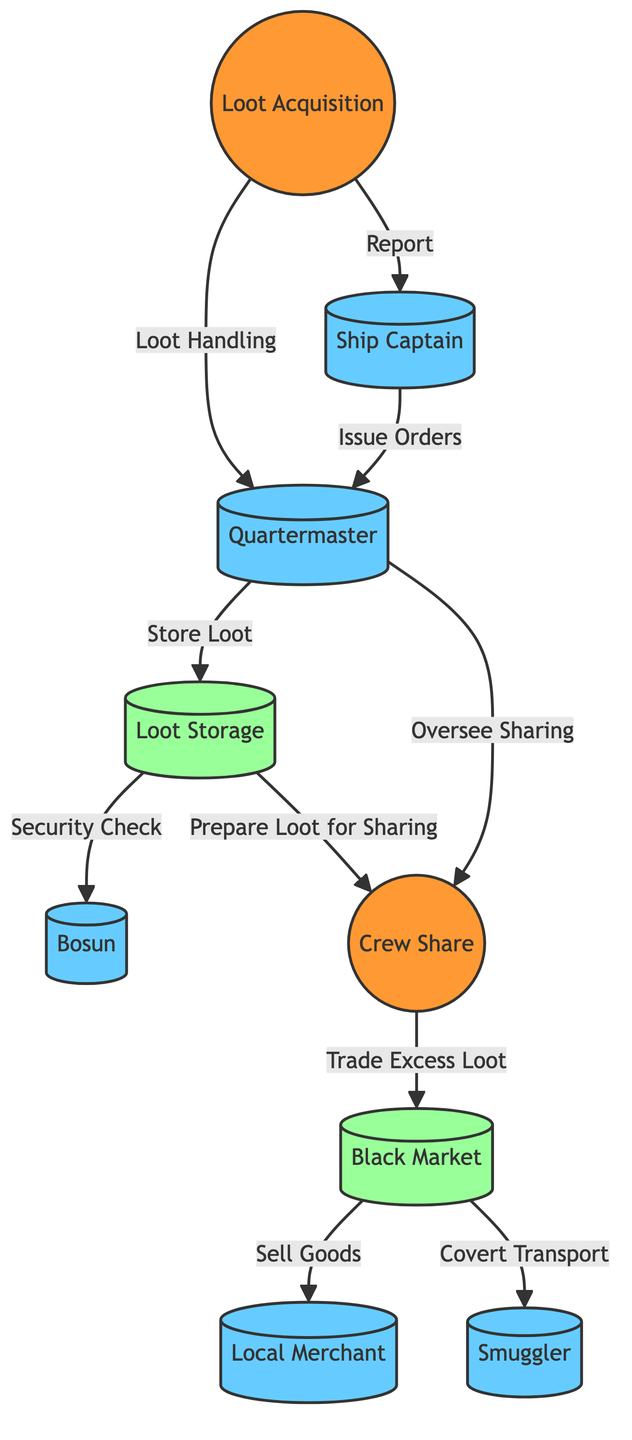What is the primary activity to obtain treasure? The primary activity to obtain treasure is "Loot Acquisition," as indicated in the diagram. This node is where the process begins and involves actions like raiding ships and finding buried treasure.
Answer: Loot Acquisition Who oversees the distribution of loot among the crew? The "Quartermaster" oversees the distribution of loot according to the diagram. The edges clearly show that the quartermaster is connected to both loot handling and crew sharing activities, indicating their oversight role.
Answer: Quartermaster How many key players are involved in the supply chain? The diagram lists four key players: the "Quartermaster," "Bosun," "Local Merchant," and "Smuggler." By counting the nodes identified as key players, we arrive at this total.
Answer: Four What follows the preparation of loot for sharing? After "Prepare Loot for Sharing," the next activity is "Crew Share." The edge connecting these two nodes indicates that crew sharing takes place once the loot is prepared.
Answer: Crew Share What is the relationship between the Quartermaster and the Ship Captain? The relationship is that the "Ship Captain" issues orders to the "Quartermaster," as depicted in the diagram. The edge clearly illustrates the flow of command and connection between these two key roles.
Answer: Issue Orders How does excess loot get handled after crew sharing? The excess loot is traded in the "Black Market," according to the diagram. The arrow shows that after crew sharing, any surplus goes to the black market for trading activities.
Answer: Trade Excess Loot What is the location where the loot is stored before distribution? "Loot Storage" is the designated location for storing booty before distribution. The diagram indicates this through an activity connected to both the quartermaster and the process of preparing loot for crew sharing.
Answer: Loot Storage What is the role of the Bosun in relation to loot storage? The Bosun is responsible for a "Security Check" of the loot stored, as shown in the diagram. This connection emphasizes the Bosun's role in maintaining safety during voyages.
Answer: Security Check Where does the Black Market sell goods from? The Black Market sells goods to "Local Merchant," as indicated in the diagram. This flow shows that after dealing with excess loot, the black market engages in selling goods to merchants.
Answer: Local Merchant Who is responsible for maintaining the ship's safety? The "Bosun" is responsible for maintaining the ship's safety during sea voyages. The diagram outlines this through the Bosun's connected activities regarding security.
Answer: Bosun 